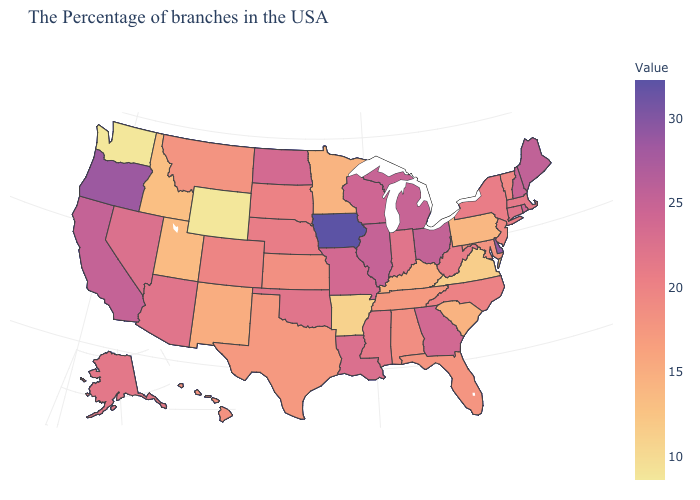Does Massachusetts have a higher value than Texas?
Keep it brief. Yes. Which states have the highest value in the USA?
Answer briefly. Iowa. Which states have the lowest value in the USA?
Keep it brief. Wyoming, Washington. Which states have the lowest value in the USA?
Keep it brief. Wyoming, Washington. 